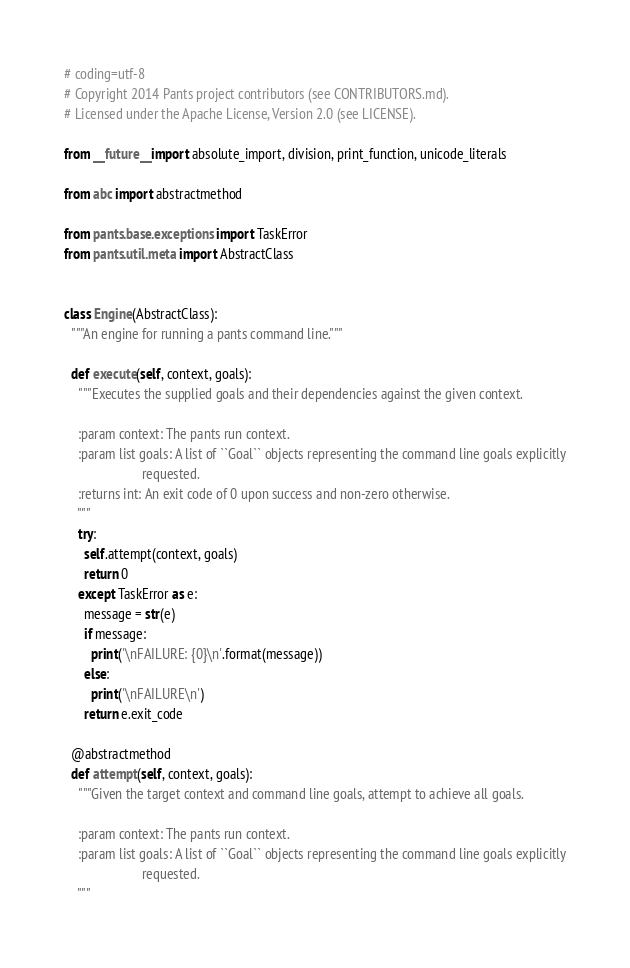<code> <loc_0><loc_0><loc_500><loc_500><_Python_># coding=utf-8
# Copyright 2014 Pants project contributors (see CONTRIBUTORS.md).
# Licensed under the Apache License, Version 2.0 (see LICENSE).

from __future__ import absolute_import, division, print_function, unicode_literals

from abc import abstractmethod

from pants.base.exceptions import TaskError
from pants.util.meta import AbstractClass


class Engine(AbstractClass):
  """An engine for running a pants command line."""

  def execute(self, context, goals):
    """Executes the supplied goals and their dependencies against the given context.

    :param context: The pants run context.
    :param list goals: A list of ``Goal`` objects representing the command line goals explicitly
                       requested.
    :returns int: An exit code of 0 upon success and non-zero otherwise.
    """
    try:
      self.attempt(context, goals)
      return 0
    except TaskError as e:
      message = str(e)
      if message:
        print('\nFAILURE: {0}\n'.format(message))
      else:
        print('\nFAILURE\n')
      return e.exit_code

  @abstractmethod
  def attempt(self, context, goals):
    """Given the target context and command line goals, attempt to achieve all goals.

    :param context: The pants run context.
    :param list goals: A list of ``Goal`` objects representing the command line goals explicitly
                       requested.
    """
</code> 